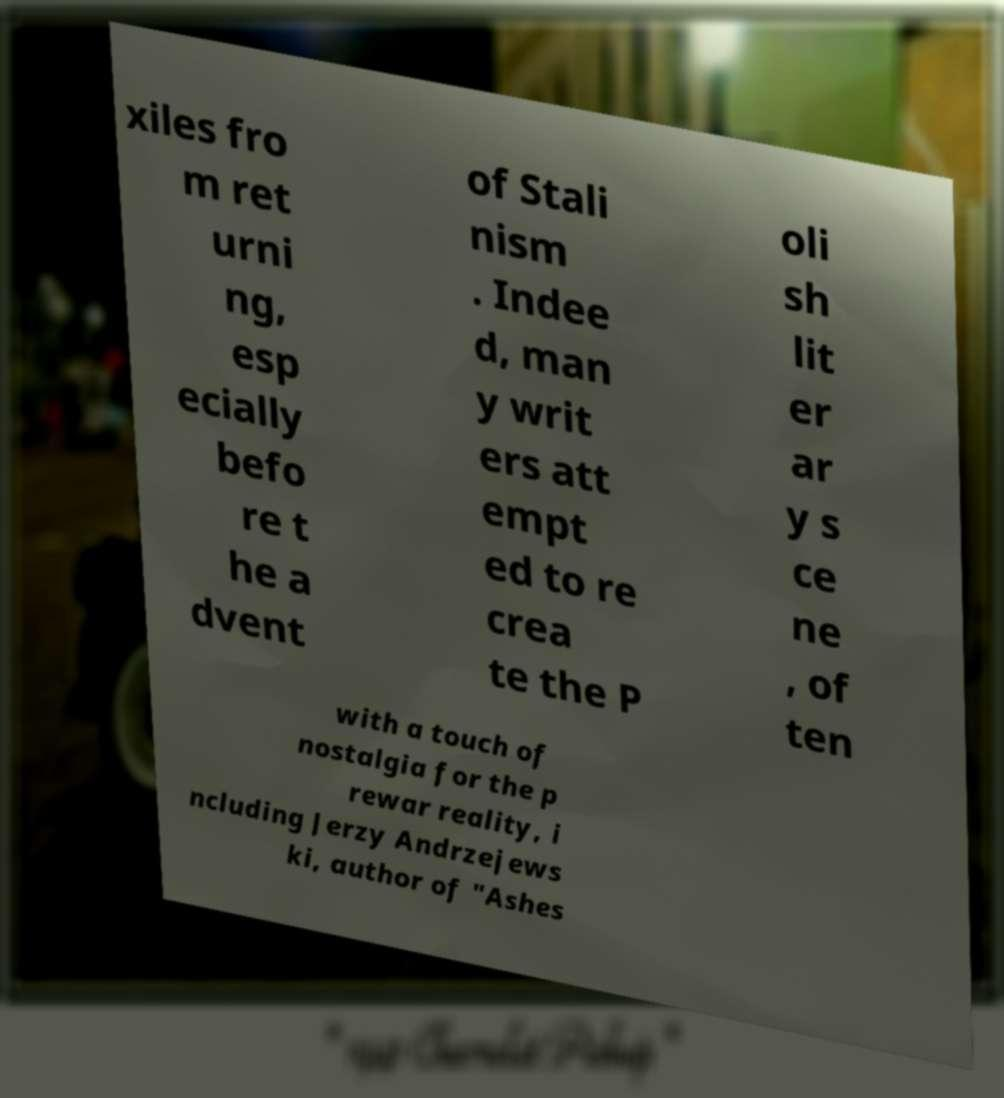Could you extract and type out the text from this image? xiles fro m ret urni ng, esp ecially befo re t he a dvent of Stali nism . Indee d, man y writ ers att empt ed to re crea te the P oli sh lit er ar y s ce ne , of ten with a touch of nostalgia for the p rewar reality, i ncluding Jerzy Andrzejews ki, author of "Ashes 